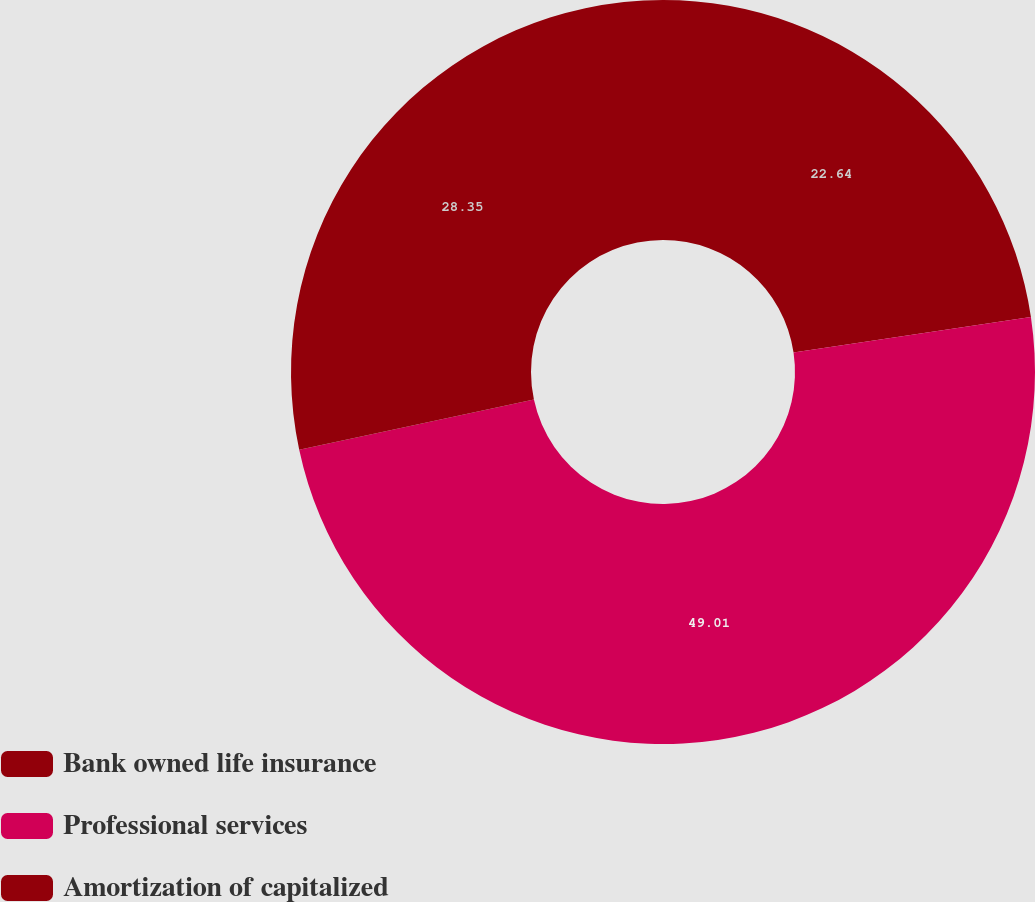<chart> <loc_0><loc_0><loc_500><loc_500><pie_chart><fcel>Bank owned life insurance<fcel>Professional services<fcel>Amortization of capitalized<nl><fcel>22.64%<fcel>49.01%<fcel>28.35%<nl></chart> 